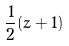Convert formula to latex. <formula><loc_0><loc_0><loc_500><loc_500>\frac { 1 } { 2 } ( z + 1 )</formula> 